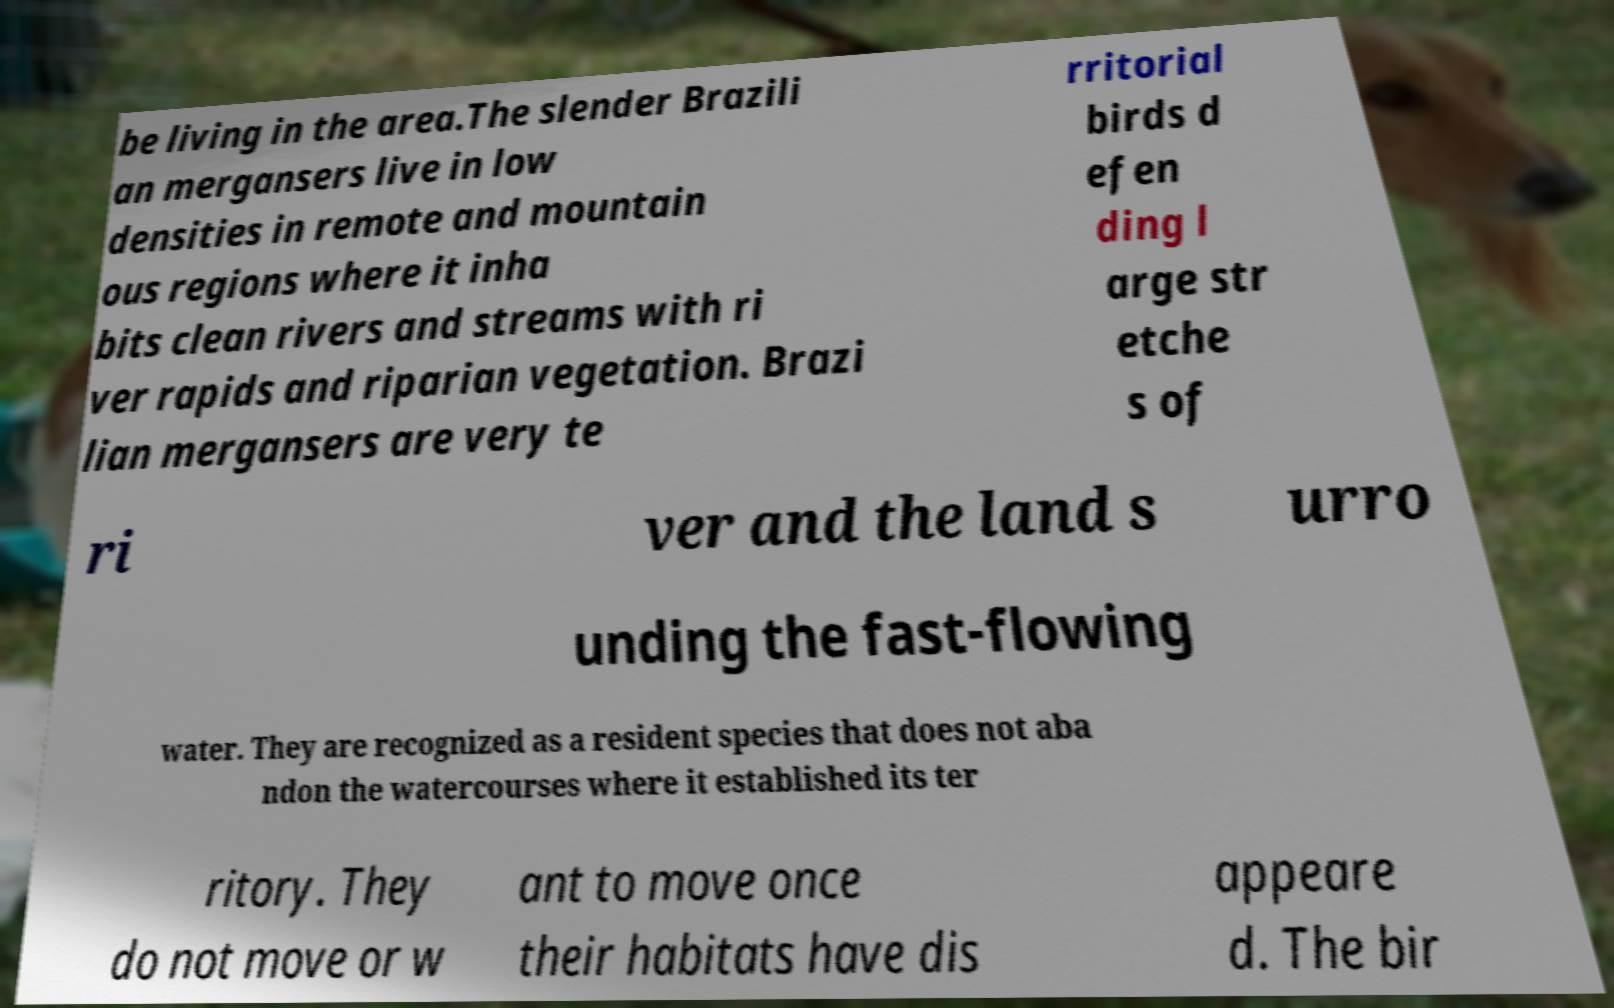For documentation purposes, I need the text within this image transcribed. Could you provide that? be living in the area.The slender Brazili an mergansers live in low densities in remote and mountain ous regions where it inha bits clean rivers and streams with ri ver rapids and riparian vegetation. Brazi lian mergansers are very te rritorial birds d efen ding l arge str etche s of ri ver and the land s urro unding the fast-flowing water. They are recognized as a resident species that does not aba ndon the watercourses where it established its ter ritory. They do not move or w ant to move once their habitats have dis appeare d. The bir 